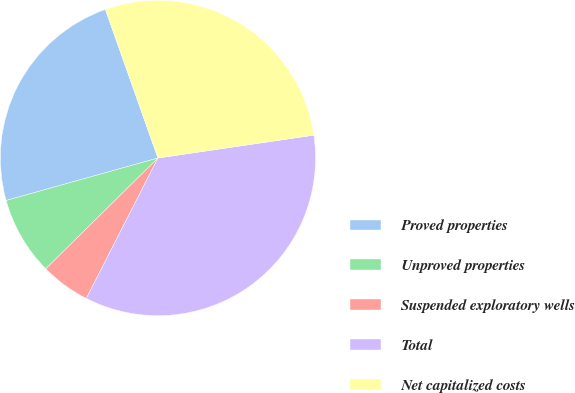Convert chart to OTSL. <chart><loc_0><loc_0><loc_500><loc_500><pie_chart><fcel>Proved properties<fcel>Unproved properties<fcel>Suspended exploratory wells<fcel>Total<fcel>Net capitalized costs<nl><fcel>23.93%<fcel>8.06%<fcel>5.09%<fcel>34.83%<fcel>28.09%<nl></chart> 